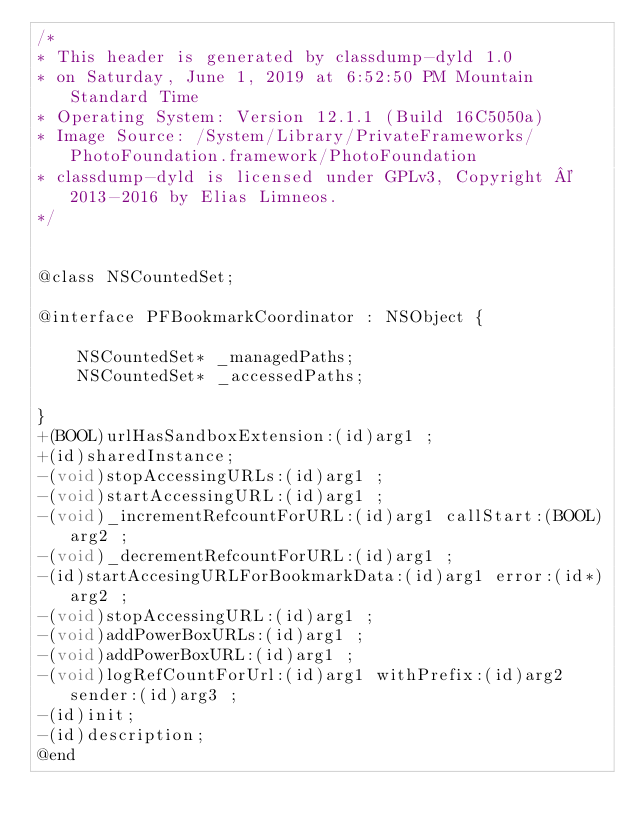Convert code to text. <code><loc_0><loc_0><loc_500><loc_500><_C_>/*
* This header is generated by classdump-dyld 1.0
* on Saturday, June 1, 2019 at 6:52:50 PM Mountain Standard Time
* Operating System: Version 12.1.1 (Build 16C5050a)
* Image Source: /System/Library/PrivateFrameworks/PhotoFoundation.framework/PhotoFoundation
* classdump-dyld is licensed under GPLv3, Copyright © 2013-2016 by Elias Limneos.
*/


@class NSCountedSet;

@interface PFBookmarkCoordinator : NSObject {

	NSCountedSet* _managedPaths;
	NSCountedSet* _accessedPaths;

}
+(BOOL)urlHasSandboxExtension:(id)arg1 ;
+(id)sharedInstance;
-(void)stopAccessingURLs:(id)arg1 ;
-(void)startAccessingURL:(id)arg1 ;
-(void)_incrementRefcountForURL:(id)arg1 callStart:(BOOL)arg2 ;
-(void)_decrementRefcountForURL:(id)arg1 ;
-(id)startAccesingURLForBookmarkData:(id)arg1 error:(id*)arg2 ;
-(void)stopAccessingURL:(id)arg1 ;
-(void)addPowerBoxURLs:(id)arg1 ;
-(void)addPowerBoxURL:(id)arg1 ;
-(void)logRefCountForUrl:(id)arg1 withPrefix:(id)arg2 sender:(id)arg3 ;
-(id)init;
-(id)description;
@end

</code> 